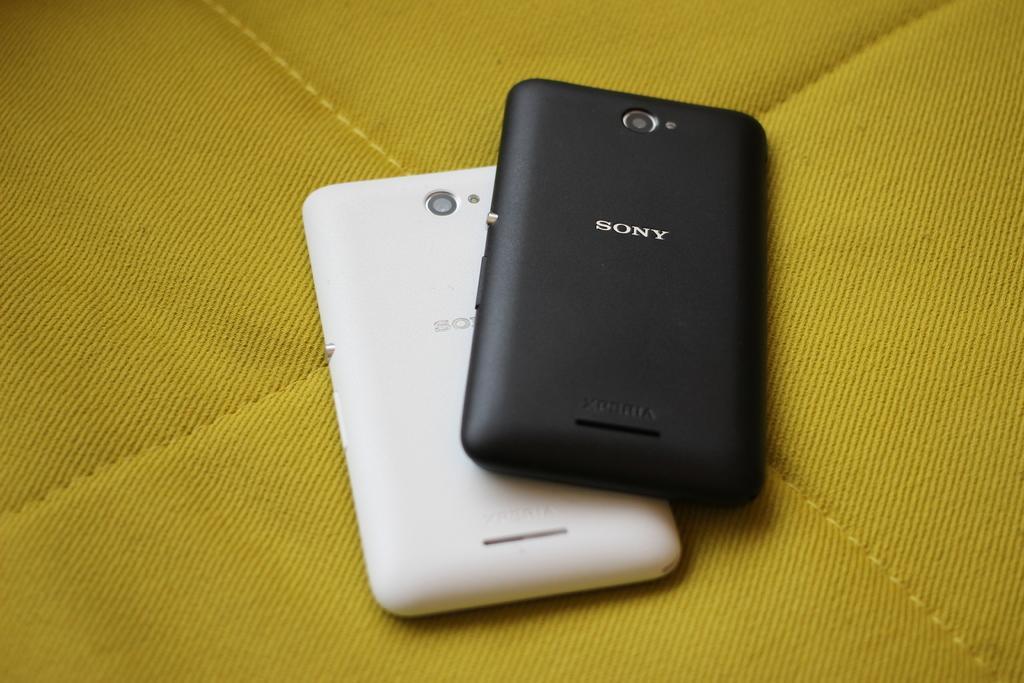How would you summarize this image in a sentence or two? In this image there are two mobiles as we can see in middle of this image. The left side mobile is in white color and the right side mobile is in black color. 